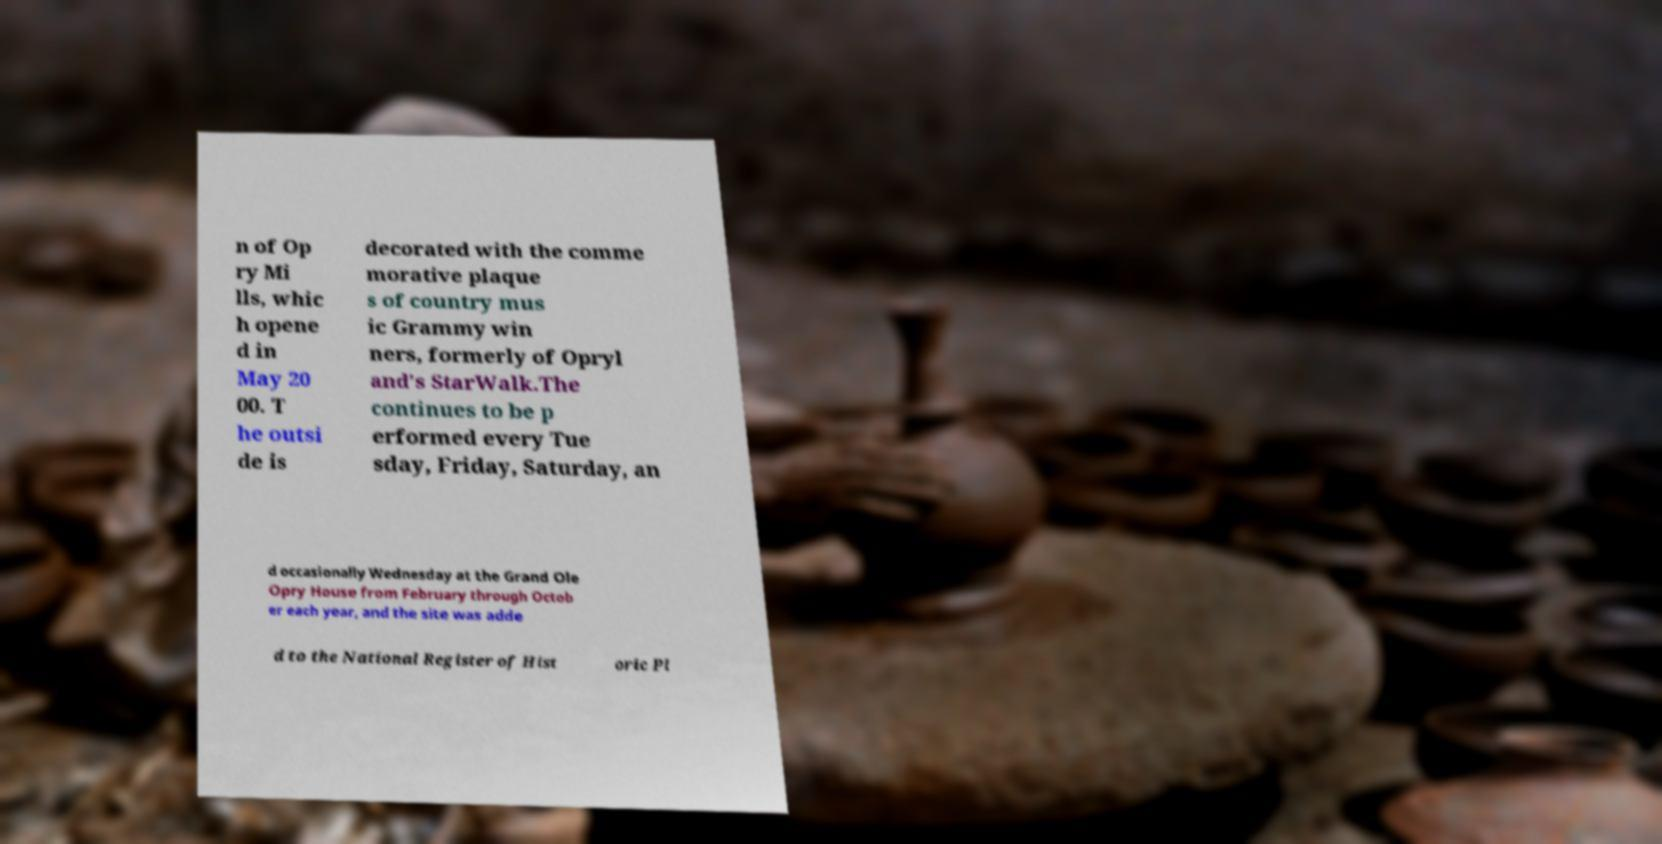I need the written content from this picture converted into text. Can you do that? n of Op ry Mi lls, whic h opene d in May 20 00. T he outsi de is decorated with the comme morative plaque s of country mus ic Grammy win ners, formerly of Opryl and's StarWalk.The continues to be p erformed every Tue sday, Friday, Saturday, an d occasionally Wednesday at the Grand Ole Opry House from February through Octob er each year, and the site was adde d to the National Register of Hist oric Pl 